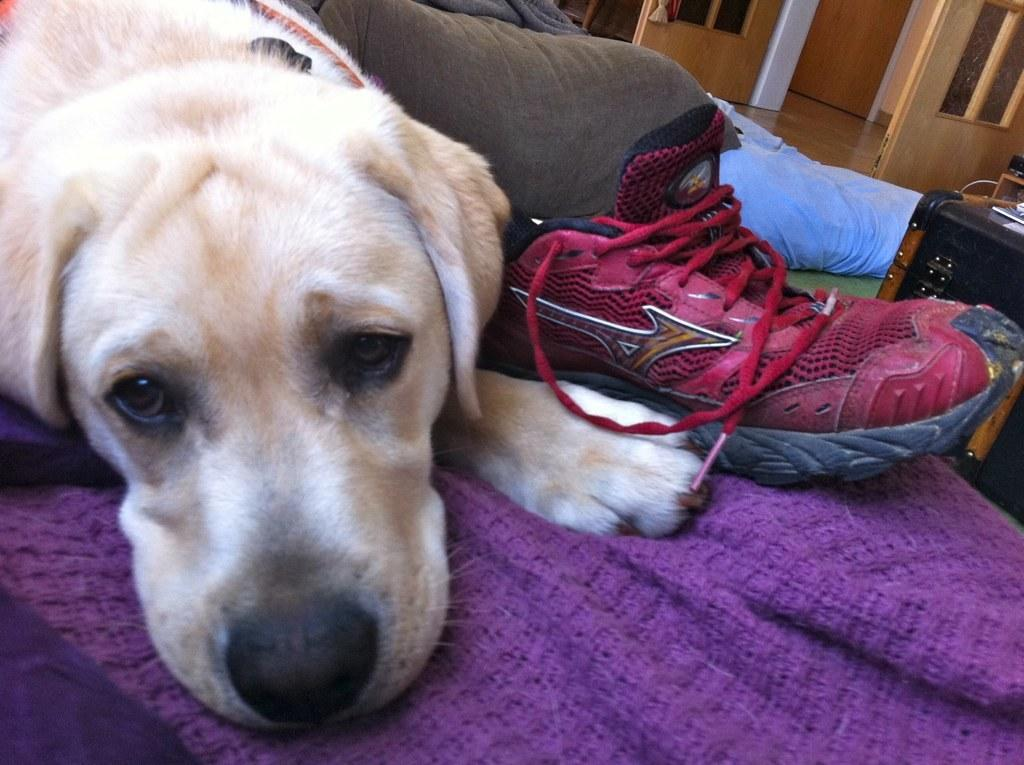What type of animal is in the image? There is a dog in the image. What is the dog doing in the image? The dog is lying on a bed. What object is beside the dog? There is a red shoe beside the dog. What type of error can be seen in the image? There is no error present in the image; it features a dog lying on a bed with a red shoe beside it. 